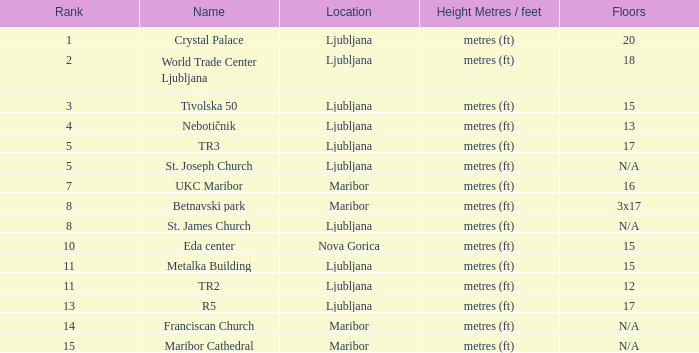What height in metres/feet corresponds to a rank of 8 and consists of 3 floors, each 17 units tall? Metres (ft). 